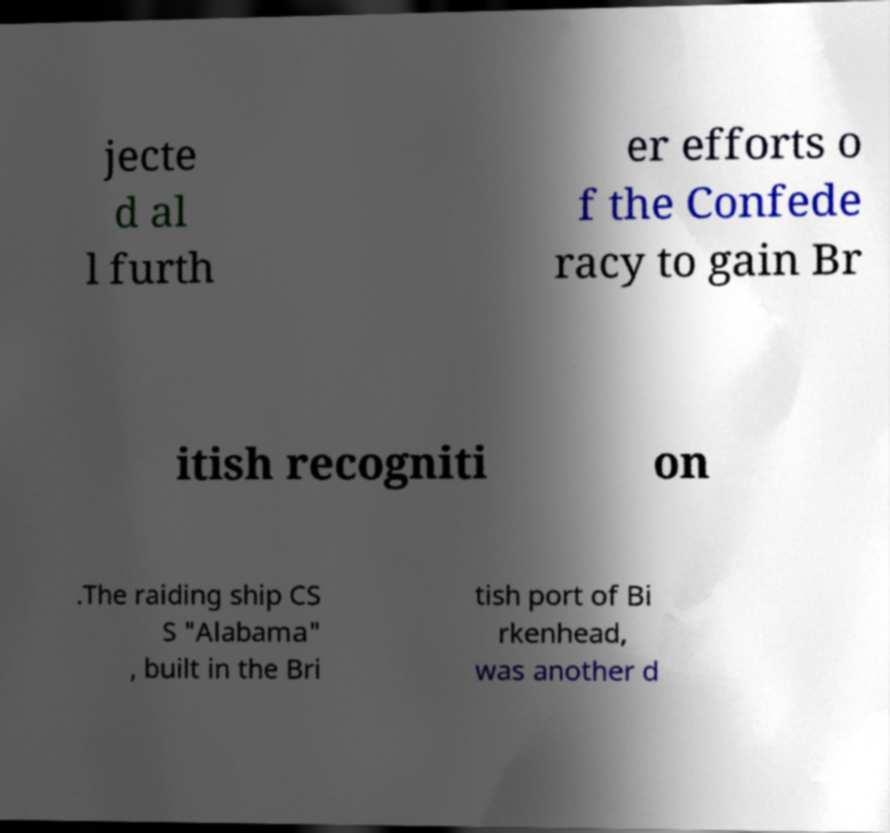Please identify and transcribe the text found in this image. jecte d al l furth er efforts o f the Confede racy to gain Br itish recogniti on .The raiding ship CS S "Alabama" , built in the Bri tish port of Bi rkenhead, was another d 